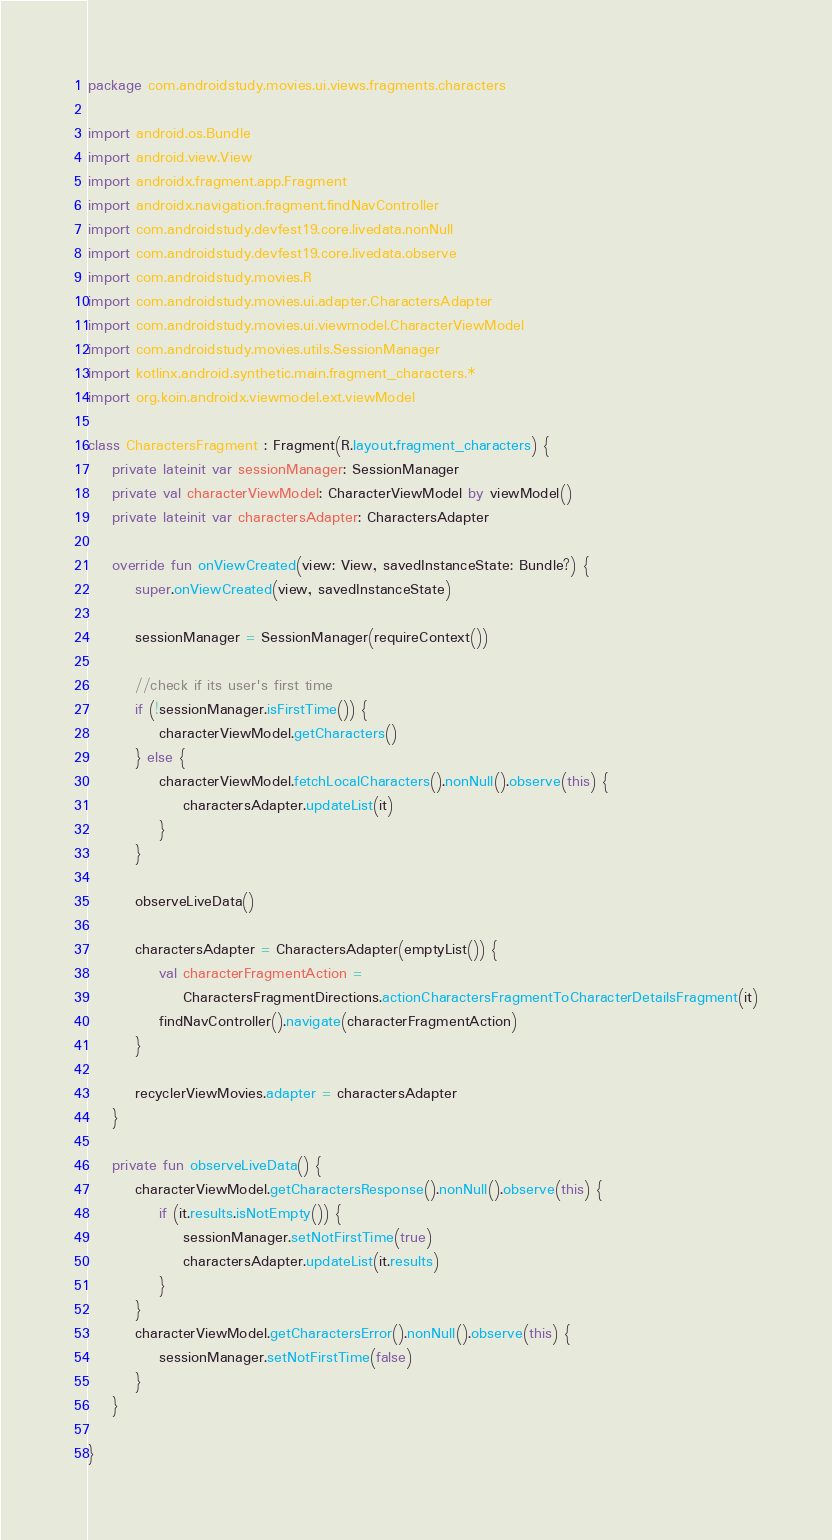<code> <loc_0><loc_0><loc_500><loc_500><_Kotlin_>package com.androidstudy.movies.ui.views.fragments.characters

import android.os.Bundle
import android.view.View
import androidx.fragment.app.Fragment
import androidx.navigation.fragment.findNavController
import com.androidstudy.devfest19.core.livedata.nonNull
import com.androidstudy.devfest19.core.livedata.observe
import com.androidstudy.movies.R
import com.androidstudy.movies.ui.adapter.CharactersAdapter
import com.androidstudy.movies.ui.viewmodel.CharacterViewModel
import com.androidstudy.movies.utils.SessionManager
import kotlinx.android.synthetic.main.fragment_characters.*
import org.koin.androidx.viewmodel.ext.viewModel

class CharactersFragment : Fragment(R.layout.fragment_characters) {
    private lateinit var sessionManager: SessionManager
    private val characterViewModel: CharacterViewModel by viewModel()
    private lateinit var charactersAdapter: CharactersAdapter

    override fun onViewCreated(view: View, savedInstanceState: Bundle?) {
        super.onViewCreated(view, savedInstanceState)

        sessionManager = SessionManager(requireContext())

        //check if its user's first time
        if (!sessionManager.isFirstTime()) {
            characterViewModel.getCharacters()
        } else {
            characterViewModel.fetchLocalCharacters().nonNull().observe(this) {
                charactersAdapter.updateList(it)
            }
        }

        observeLiveData()

        charactersAdapter = CharactersAdapter(emptyList()) {
            val characterFragmentAction =
                CharactersFragmentDirections.actionCharactersFragmentToCharacterDetailsFragment(it)
            findNavController().navigate(characterFragmentAction)
        }

        recyclerViewMovies.adapter = charactersAdapter
    }

    private fun observeLiveData() {
        characterViewModel.getCharactersResponse().nonNull().observe(this) {
            if (it.results.isNotEmpty()) {
                sessionManager.setNotFirstTime(true)
                charactersAdapter.updateList(it.results)
            }
        }
        characterViewModel.getCharactersError().nonNull().observe(this) {
            sessionManager.setNotFirstTime(false)
        }
    }

}</code> 